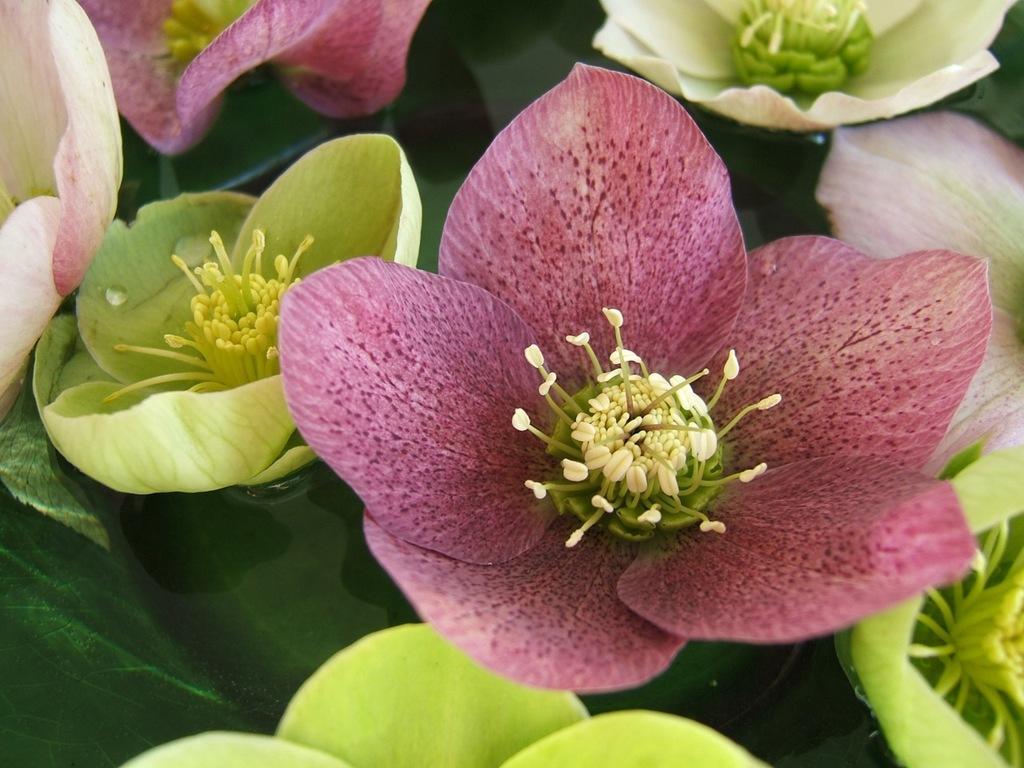Describe this image in one or two sentences. In this image there are flowers and leaves. 